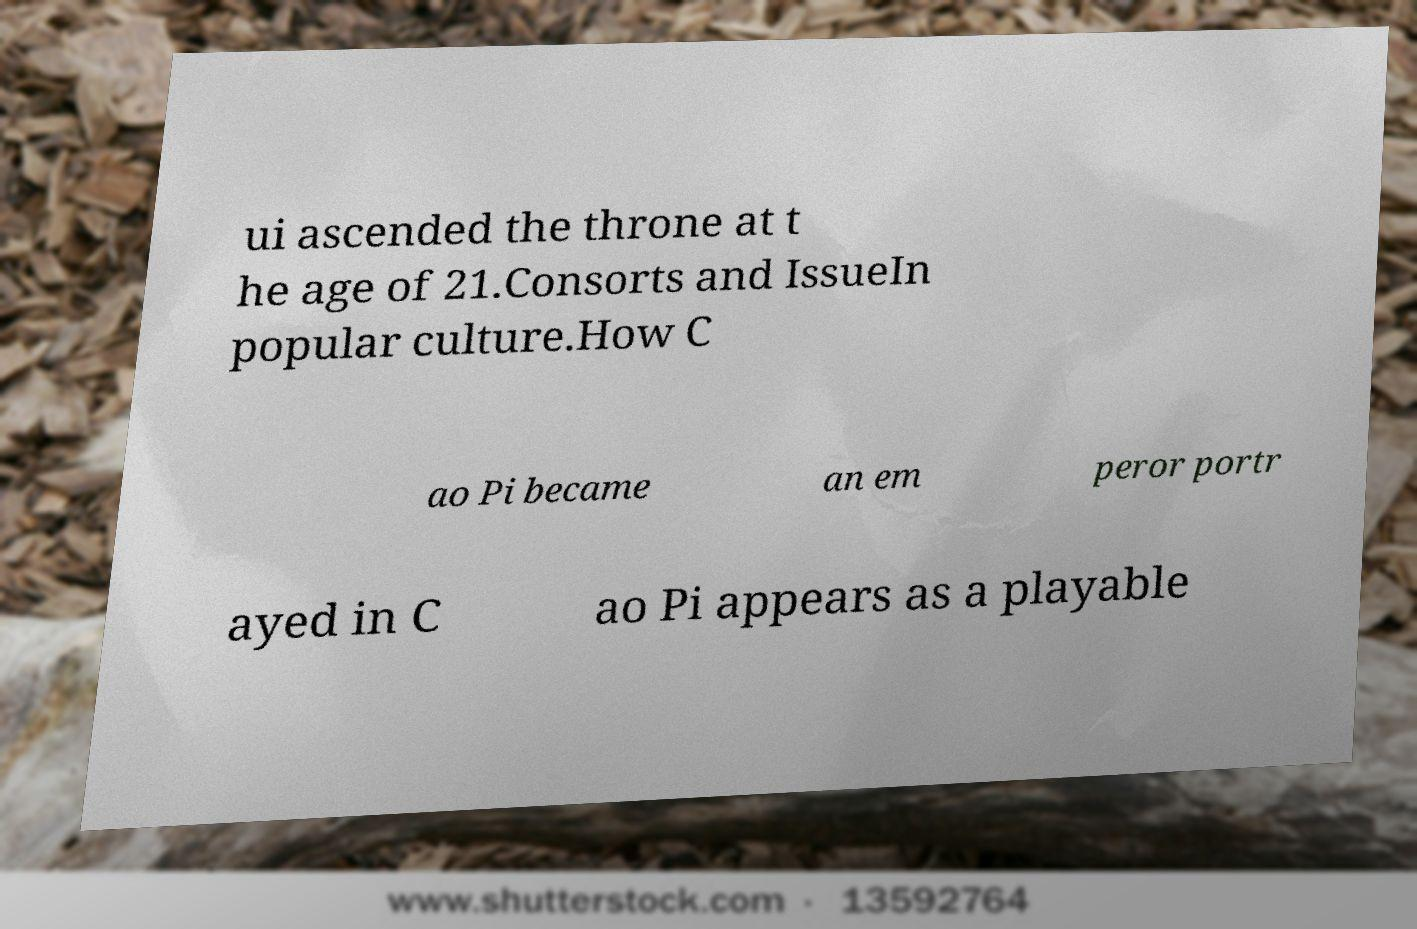Can you accurately transcribe the text from the provided image for me? ui ascended the throne at t he age of 21.Consorts and IssueIn popular culture.How C ao Pi became an em peror portr ayed in C ao Pi appears as a playable 